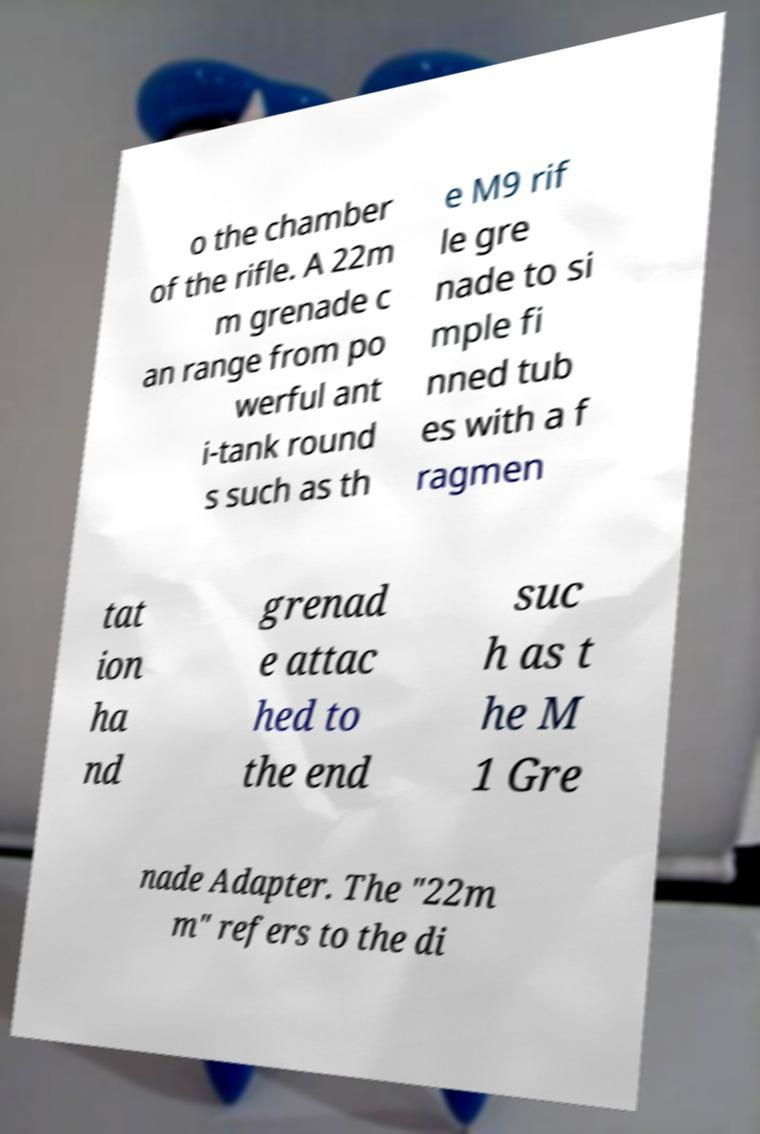I need the written content from this picture converted into text. Can you do that? o the chamber of the rifle. A 22m m grenade c an range from po werful ant i-tank round s such as th e M9 rif le gre nade to si mple fi nned tub es with a f ragmen tat ion ha nd grenad e attac hed to the end suc h as t he M 1 Gre nade Adapter. The "22m m" refers to the di 